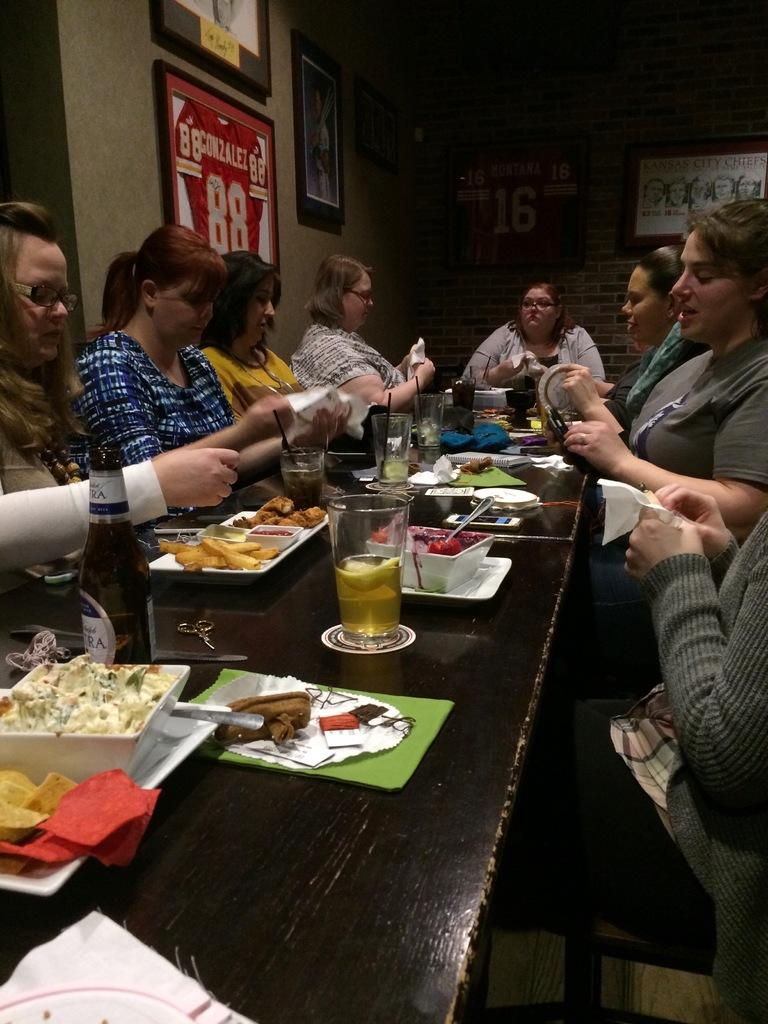How many people are in the image? There is a group of people in the image, but the exact number is not specified. What are the people doing in the image? The people are sitting in front of a table. What can be seen on the table in the image? There are bottles, glasses, and other objects on the table. Can you see a horse running in the image? There is no horse or any running activity present in the image. 